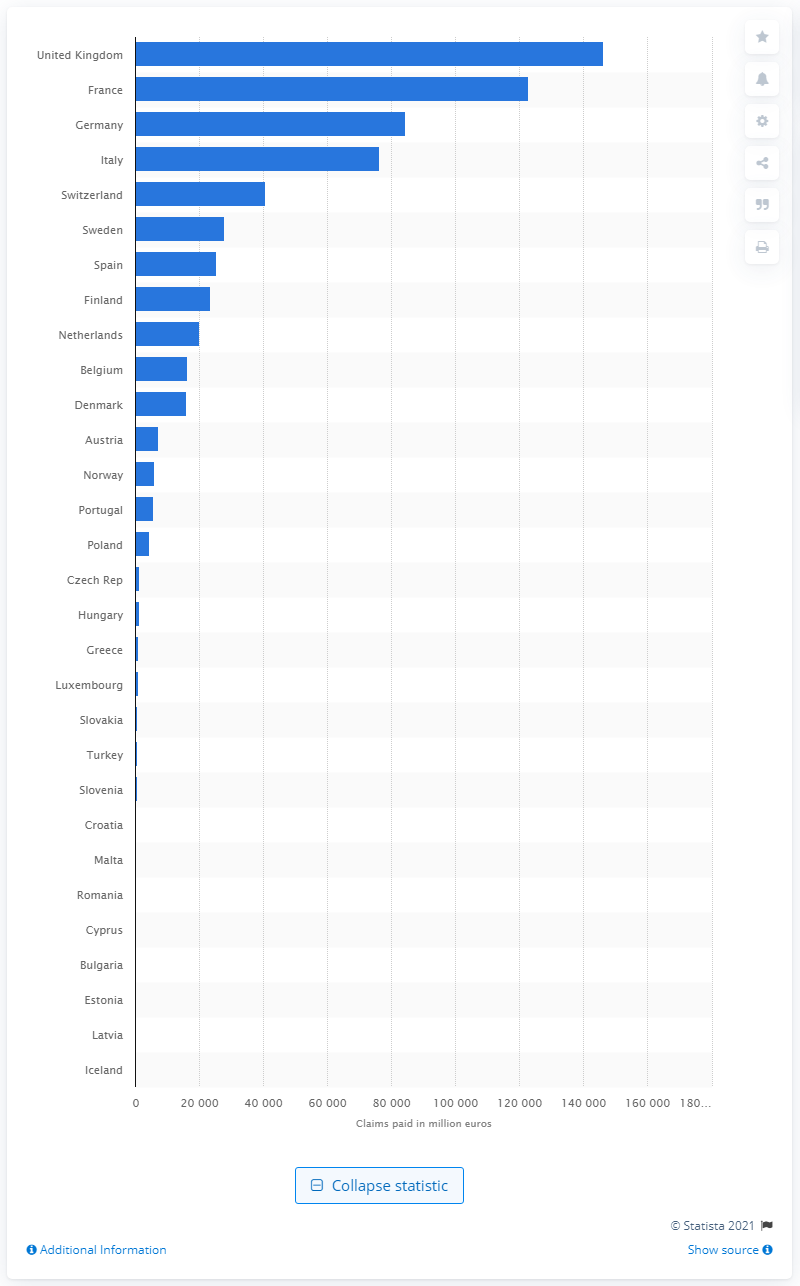Mention a couple of crucial points in this snapshot. In 2019, the total amount of life claims paid in the UK was 146,121. The total amount of life claims paid on the European insurance market in 2019 was 844,848. 